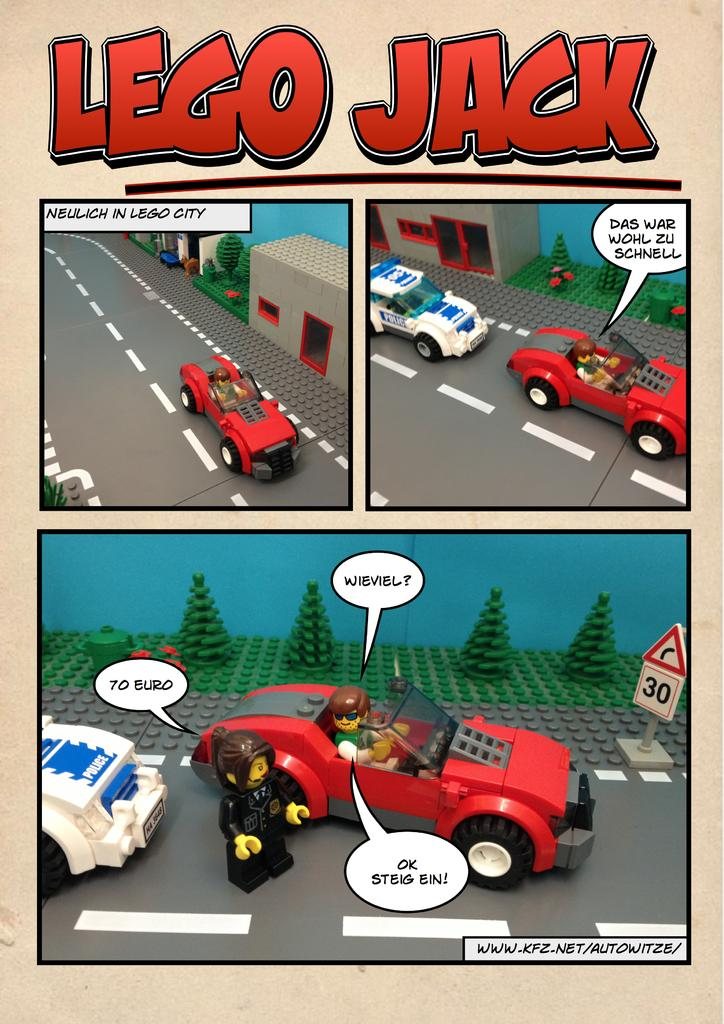What is featured in the image? There is a poster in the image. What type of images are on the poster? The poster contains cartoon pictures. Are there any words on the poster? Yes, there is text on the poster. What flavor of toothpaste is shown in the cartoon pictures on the poster? There is no toothpaste present in the image, as the poster contains cartoon pictures but no toothpaste. 